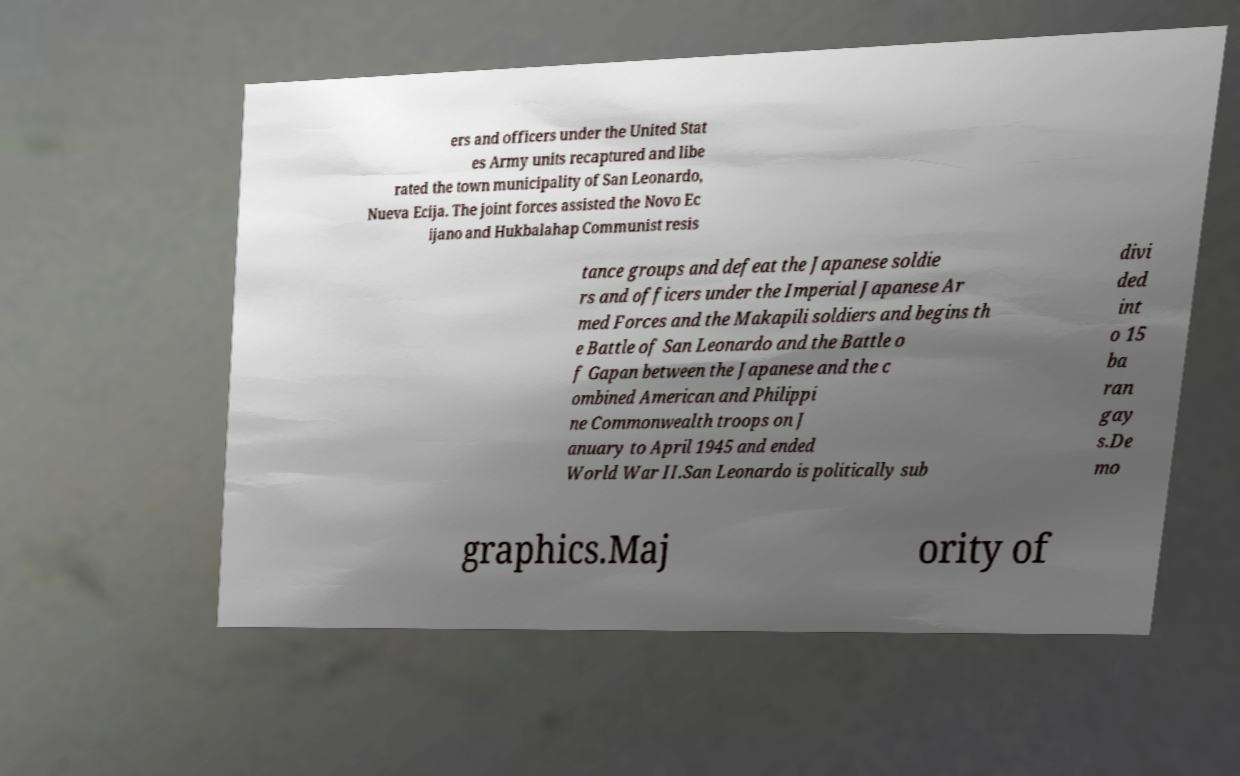What messages or text are displayed in this image? I need them in a readable, typed format. ers and officers under the United Stat es Army units recaptured and libe rated the town municipality of San Leonardo, Nueva Ecija. The joint forces assisted the Novo Ec ijano and Hukbalahap Communist resis tance groups and defeat the Japanese soldie rs and officers under the Imperial Japanese Ar med Forces and the Makapili soldiers and begins th e Battle of San Leonardo and the Battle o f Gapan between the Japanese and the c ombined American and Philippi ne Commonwealth troops on J anuary to April 1945 and ended World War II.San Leonardo is politically sub divi ded int o 15 ba ran gay s.De mo graphics.Maj ority of 